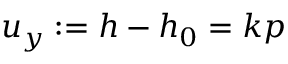Convert formula to latex. <formula><loc_0><loc_0><loc_500><loc_500>u _ { y } \colon = h - h _ { 0 } = k p</formula> 